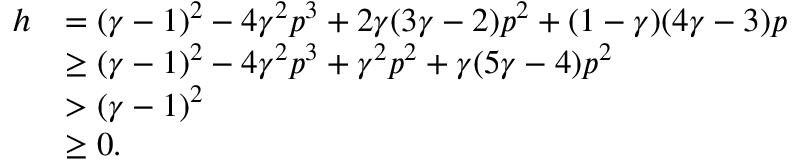Convert formula to latex. <formula><loc_0><loc_0><loc_500><loc_500>\begin{array} { r l } { h } & { = ( \gamma - 1 ) ^ { 2 } - 4 \gamma ^ { 2 } p ^ { 3 } + 2 \gamma ( 3 \gamma - 2 ) p ^ { 2 } + ( 1 - \gamma ) ( 4 \gamma - 3 ) p } \\ & { \geq ( \gamma - 1 ) ^ { 2 } - 4 \gamma ^ { 2 } p ^ { 3 } + \gamma ^ { 2 } p ^ { 2 } + \gamma ( 5 \gamma - 4 ) p ^ { 2 } } \\ & { > ( \gamma - 1 ) ^ { 2 } } \\ & { \geq 0 . } \end{array}</formula> 